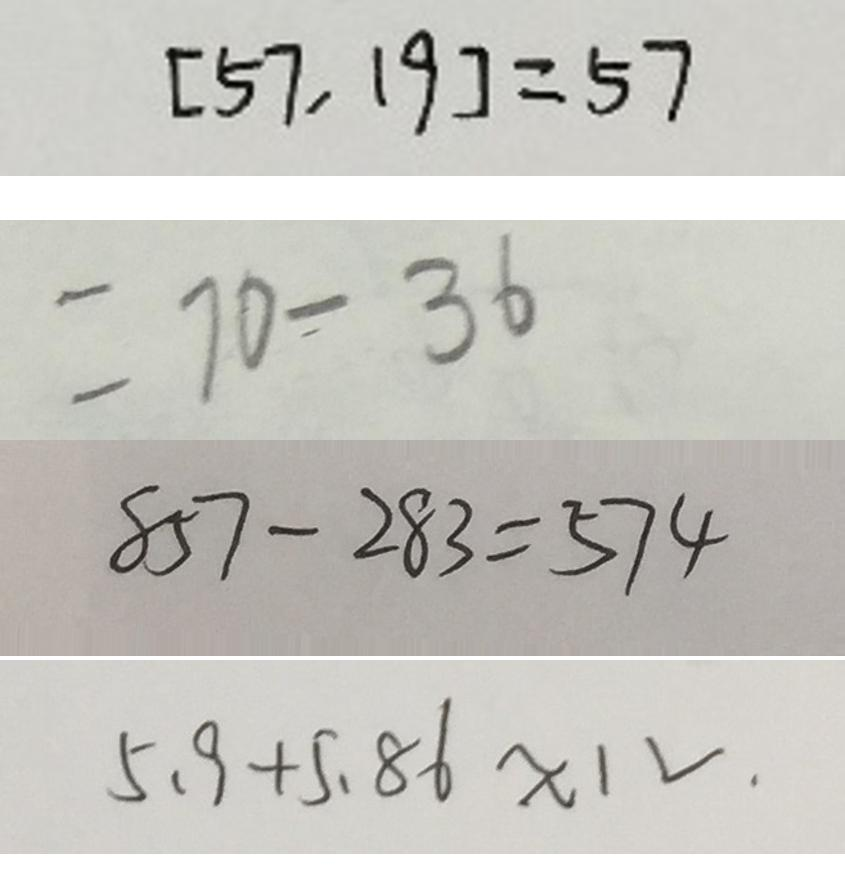Convert formula to latex. <formula><loc_0><loc_0><loc_500><loc_500>[ 5 7 , 1 9 ] = 5 7 
 = 7 0 - 3 6 
 8 5 7 - 2 8 3 = 5 7 4 
 5 . 9 + 5 . 8 6 \approx 1 V .</formula> 